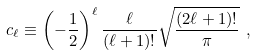<formula> <loc_0><loc_0><loc_500><loc_500>c _ { \ell } \equiv \left ( - \frac { 1 } { 2 } \right ) ^ { \ell } \frac { \ell } { ( \ell + 1 ) ! } \sqrt { \frac { ( 2 \ell + 1 ) ! } { \pi } } \ ,</formula> 